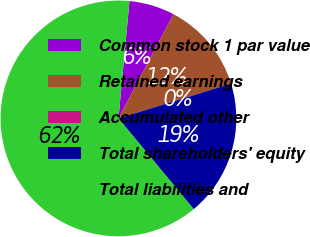<chart> <loc_0><loc_0><loc_500><loc_500><pie_chart><fcel>Common stock 1 par value<fcel>Retained earnings<fcel>Accumulated other<fcel>Total shareholders' equity<fcel>Total liabilities and<nl><fcel>6.25%<fcel>12.5%<fcel>0.0%<fcel>18.75%<fcel>62.5%<nl></chart> 